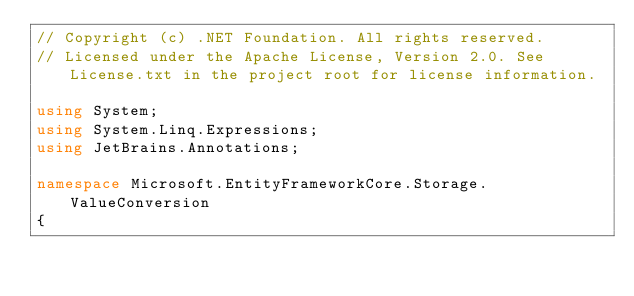<code> <loc_0><loc_0><loc_500><loc_500><_C#_>// Copyright (c) .NET Foundation. All rights reserved.
// Licensed under the Apache License, Version 2.0. See License.txt in the project root for license information.

using System;
using System.Linq.Expressions;
using JetBrains.Annotations;

namespace Microsoft.EntityFrameworkCore.Storage.ValueConversion
{</code> 